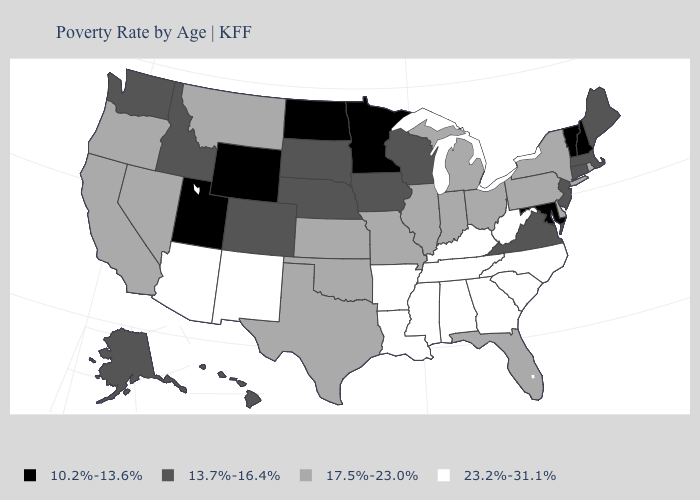Which states hav the highest value in the West?
Be succinct. Arizona, New Mexico. Does the first symbol in the legend represent the smallest category?
Write a very short answer. Yes. Among the states that border Utah , does New Mexico have the highest value?
Be succinct. Yes. Which states have the lowest value in the USA?
Quick response, please. Maryland, Minnesota, New Hampshire, North Dakota, Utah, Vermont, Wyoming. What is the value of Virginia?
Answer briefly. 13.7%-16.4%. Name the states that have a value in the range 17.5%-23.0%?
Concise answer only. California, Delaware, Florida, Illinois, Indiana, Kansas, Michigan, Missouri, Montana, Nevada, New York, Ohio, Oklahoma, Oregon, Pennsylvania, Rhode Island, Texas. Does the first symbol in the legend represent the smallest category?
Give a very brief answer. Yes. Does the first symbol in the legend represent the smallest category?
Write a very short answer. Yes. What is the value of Georgia?
Write a very short answer. 23.2%-31.1%. Does Wyoming have the same value as Nevada?
Short answer required. No. What is the value of Kentucky?
Answer briefly. 23.2%-31.1%. What is the value of Minnesota?
Concise answer only. 10.2%-13.6%. Among the states that border South Carolina , which have the highest value?
Quick response, please. Georgia, North Carolina. What is the value of Connecticut?
Give a very brief answer. 13.7%-16.4%. How many symbols are there in the legend?
Answer briefly. 4. 